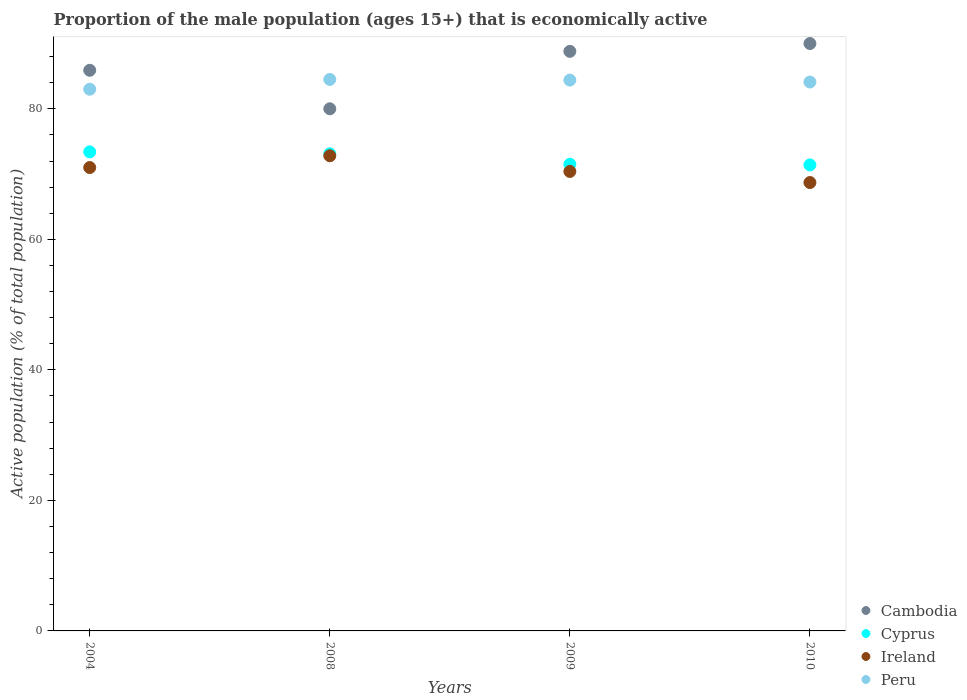What is the proportion of the male population that is economically active in Peru in 2008?
Provide a short and direct response. 84.5. Across all years, what is the maximum proportion of the male population that is economically active in Peru?
Keep it short and to the point. 84.5. What is the total proportion of the male population that is economically active in Ireland in the graph?
Make the answer very short. 282.9. What is the difference between the proportion of the male population that is economically active in Ireland in 2008 and that in 2009?
Offer a very short reply. 2.4. What is the difference between the proportion of the male population that is economically active in Cambodia in 2004 and the proportion of the male population that is economically active in Cyprus in 2010?
Offer a very short reply. 14.5. What is the average proportion of the male population that is economically active in Ireland per year?
Give a very brief answer. 70.73. In the year 2010, what is the difference between the proportion of the male population that is economically active in Peru and proportion of the male population that is economically active in Cambodia?
Provide a succinct answer. -5.9. In how many years, is the proportion of the male population that is economically active in Cyprus greater than 12 %?
Keep it short and to the point. 4. What is the ratio of the proportion of the male population that is economically active in Cyprus in 2008 to that in 2010?
Your answer should be compact. 1.02. What is the difference between the highest and the second highest proportion of the male population that is economically active in Ireland?
Your response must be concise. 1.8. What is the difference between the highest and the lowest proportion of the male population that is economically active in Cyprus?
Provide a succinct answer. 2. Is it the case that in every year, the sum of the proportion of the male population that is economically active in Cyprus and proportion of the male population that is economically active in Peru  is greater than the sum of proportion of the male population that is economically active in Ireland and proportion of the male population that is economically active in Cambodia?
Your answer should be very brief. No. Is it the case that in every year, the sum of the proportion of the male population that is economically active in Cyprus and proportion of the male population that is economically active in Cambodia  is greater than the proportion of the male population that is economically active in Ireland?
Keep it short and to the point. Yes. Does the proportion of the male population that is economically active in Cambodia monotonically increase over the years?
Give a very brief answer. No. Is the proportion of the male population that is economically active in Ireland strictly greater than the proportion of the male population that is economically active in Cyprus over the years?
Provide a short and direct response. No. How many years are there in the graph?
Keep it short and to the point. 4. Are the values on the major ticks of Y-axis written in scientific E-notation?
Offer a terse response. No. Does the graph contain any zero values?
Provide a succinct answer. No. Where does the legend appear in the graph?
Your response must be concise. Bottom right. How are the legend labels stacked?
Give a very brief answer. Vertical. What is the title of the graph?
Keep it short and to the point. Proportion of the male population (ages 15+) that is economically active. What is the label or title of the X-axis?
Your response must be concise. Years. What is the label or title of the Y-axis?
Provide a succinct answer. Active population (% of total population). What is the Active population (% of total population) in Cambodia in 2004?
Provide a short and direct response. 85.9. What is the Active population (% of total population) in Cyprus in 2004?
Give a very brief answer. 73.4. What is the Active population (% of total population) of Ireland in 2004?
Keep it short and to the point. 71. What is the Active population (% of total population) in Peru in 2004?
Make the answer very short. 83. What is the Active population (% of total population) of Cambodia in 2008?
Offer a terse response. 80. What is the Active population (% of total population) of Cyprus in 2008?
Ensure brevity in your answer.  73.1. What is the Active population (% of total population) in Ireland in 2008?
Provide a succinct answer. 72.8. What is the Active population (% of total population) of Peru in 2008?
Your answer should be very brief. 84.5. What is the Active population (% of total population) in Cambodia in 2009?
Ensure brevity in your answer.  88.8. What is the Active population (% of total population) of Cyprus in 2009?
Ensure brevity in your answer.  71.5. What is the Active population (% of total population) in Ireland in 2009?
Give a very brief answer. 70.4. What is the Active population (% of total population) in Peru in 2009?
Keep it short and to the point. 84.4. What is the Active population (% of total population) of Cambodia in 2010?
Your answer should be very brief. 90. What is the Active population (% of total population) in Cyprus in 2010?
Provide a succinct answer. 71.4. What is the Active population (% of total population) in Ireland in 2010?
Keep it short and to the point. 68.7. What is the Active population (% of total population) in Peru in 2010?
Offer a terse response. 84.1. Across all years, what is the maximum Active population (% of total population) in Cambodia?
Ensure brevity in your answer.  90. Across all years, what is the maximum Active population (% of total population) in Cyprus?
Give a very brief answer. 73.4. Across all years, what is the maximum Active population (% of total population) of Ireland?
Provide a succinct answer. 72.8. Across all years, what is the maximum Active population (% of total population) of Peru?
Your answer should be compact. 84.5. Across all years, what is the minimum Active population (% of total population) in Cambodia?
Offer a terse response. 80. Across all years, what is the minimum Active population (% of total population) of Cyprus?
Your response must be concise. 71.4. Across all years, what is the minimum Active population (% of total population) of Ireland?
Your answer should be very brief. 68.7. Across all years, what is the minimum Active population (% of total population) in Peru?
Ensure brevity in your answer.  83. What is the total Active population (% of total population) in Cambodia in the graph?
Offer a terse response. 344.7. What is the total Active population (% of total population) in Cyprus in the graph?
Offer a very short reply. 289.4. What is the total Active population (% of total population) of Ireland in the graph?
Ensure brevity in your answer.  282.9. What is the total Active population (% of total population) of Peru in the graph?
Offer a terse response. 336. What is the difference between the Active population (% of total population) in Peru in 2004 and that in 2008?
Keep it short and to the point. -1.5. What is the difference between the Active population (% of total population) in Peru in 2004 and that in 2009?
Keep it short and to the point. -1.4. What is the difference between the Active population (% of total population) of Cambodia in 2004 and that in 2010?
Give a very brief answer. -4.1. What is the difference between the Active population (% of total population) in Cyprus in 2004 and that in 2010?
Keep it short and to the point. 2. What is the difference between the Active population (% of total population) in Ireland in 2004 and that in 2010?
Your response must be concise. 2.3. What is the difference between the Active population (% of total population) of Cambodia in 2008 and that in 2009?
Keep it short and to the point. -8.8. What is the difference between the Active population (% of total population) in Cyprus in 2008 and that in 2009?
Give a very brief answer. 1.6. What is the difference between the Active population (% of total population) of Ireland in 2008 and that in 2009?
Provide a short and direct response. 2.4. What is the difference between the Active population (% of total population) of Peru in 2008 and that in 2009?
Your response must be concise. 0.1. What is the difference between the Active population (% of total population) in Cambodia in 2008 and that in 2010?
Keep it short and to the point. -10. What is the difference between the Active population (% of total population) of Cyprus in 2008 and that in 2010?
Ensure brevity in your answer.  1.7. What is the difference between the Active population (% of total population) in Peru in 2008 and that in 2010?
Offer a very short reply. 0.4. What is the difference between the Active population (% of total population) in Cambodia in 2009 and that in 2010?
Your response must be concise. -1.2. What is the difference between the Active population (% of total population) in Cyprus in 2009 and that in 2010?
Provide a short and direct response. 0.1. What is the difference between the Active population (% of total population) in Ireland in 2009 and that in 2010?
Make the answer very short. 1.7. What is the difference between the Active population (% of total population) of Peru in 2009 and that in 2010?
Provide a short and direct response. 0.3. What is the difference between the Active population (% of total population) of Cambodia in 2004 and the Active population (% of total population) of Ireland in 2008?
Make the answer very short. 13.1. What is the difference between the Active population (% of total population) of Cyprus in 2004 and the Active population (% of total population) of Ireland in 2008?
Offer a very short reply. 0.6. What is the difference between the Active population (% of total population) of Cambodia in 2004 and the Active population (% of total population) of Peru in 2009?
Your answer should be very brief. 1.5. What is the difference between the Active population (% of total population) of Cyprus in 2004 and the Active population (% of total population) of Ireland in 2009?
Provide a short and direct response. 3. What is the difference between the Active population (% of total population) of Ireland in 2004 and the Active population (% of total population) of Peru in 2009?
Your answer should be very brief. -13.4. What is the difference between the Active population (% of total population) in Cambodia in 2004 and the Active population (% of total population) in Cyprus in 2010?
Offer a very short reply. 14.5. What is the difference between the Active population (% of total population) of Ireland in 2004 and the Active population (% of total population) of Peru in 2010?
Keep it short and to the point. -13.1. What is the difference between the Active population (% of total population) of Cambodia in 2008 and the Active population (% of total population) of Cyprus in 2009?
Make the answer very short. 8.5. What is the difference between the Active population (% of total population) of Cambodia in 2008 and the Active population (% of total population) of Ireland in 2009?
Keep it short and to the point. 9.6. What is the difference between the Active population (% of total population) of Cambodia in 2008 and the Active population (% of total population) of Peru in 2009?
Your response must be concise. -4.4. What is the difference between the Active population (% of total population) of Cyprus in 2008 and the Active population (% of total population) of Ireland in 2010?
Provide a short and direct response. 4.4. What is the difference between the Active population (% of total population) in Cyprus in 2008 and the Active population (% of total population) in Peru in 2010?
Provide a succinct answer. -11. What is the difference between the Active population (% of total population) in Ireland in 2008 and the Active population (% of total population) in Peru in 2010?
Your response must be concise. -11.3. What is the difference between the Active population (% of total population) of Cambodia in 2009 and the Active population (% of total population) of Cyprus in 2010?
Offer a terse response. 17.4. What is the difference between the Active population (% of total population) of Cambodia in 2009 and the Active population (% of total population) of Ireland in 2010?
Provide a succinct answer. 20.1. What is the difference between the Active population (% of total population) in Cambodia in 2009 and the Active population (% of total population) in Peru in 2010?
Your answer should be compact. 4.7. What is the difference between the Active population (% of total population) of Cyprus in 2009 and the Active population (% of total population) of Ireland in 2010?
Ensure brevity in your answer.  2.8. What is the difference between the Active population (% of total population) in Ireland in 2009 and the Active population (% of total population) in Peru in 2010?
Provide a succinct answer. -13.7. What is the average Active population (% of total population) of Cambodia per year?
Your answer should be compact. 86.17. What is the average Active population (% of total population) in Cyprus per year?
Keep it short and to the point. 72.35. What is the average Active population (% of total population) of Ireland per year?
Offer a very short reply. 70.72. What is the average Active population (% of total population) of Peru per year?
Make the answer very short. 84. In the year 2004, what is the difference between the Active population (% of total population) in Cambodia and Active population (% of total population) in Cyprus?
Offer a very short reply. 12.5. In the year 2008, what is the difference between the Active population (% of total population) of Cambodia and Active population (% of total population) of Peru?
Ensure brevity in your answer.  -4.5. In the year 2008, what is the difference between the Active population (% of total population) in Cyprus and Active population (% of total population) in Ireland?
Offer a very short reply. 0.3. In the year 2008, what is the difference between the Active population (% of total population) of Cyprus and Active population (% of total population) of Peru?
Make the answer very short. -11.4. In the year 2009, what is the difference between the Active population (% of total population) of Cambodia and Active population (% of total population) of Cyprus?
Ensure brevity in your answer.  17.3. In the year 2009, what is the difference between the Active population (% of total population) of Cambodia and Active population (% of total population) of Ireland?
Your response must be concise. 18.4. In the year 2009, what is the difference between the Active population (% of total population) in Cambodia and Active population (% of total population) in Peru?
Offer a terse response. 4.4. In the year 2010, what is the difference between the Active population (% of total population) in Cambodia and Active population (% of total population) in Cyprus?
Offer a very short reply. 18.6. In the year 2010, what is the difference between the Active population (% of total population) in Cambodia and Active population (% of total population) in Ireland?
Offer a very short reply. 21.3. In the year 2010, what is the difference between the Active population (% of total population) of Cambodia and Active population (% of total population) of Peru?
Offer a very short reply. 5.9. In the year 2010, what is the difference between the Active population (% of total population) in Cyprus and Active population (% of total population) in Ireland?
Make the answer very short. 2.7. In the year 2010, what is the difference between the Active population (% of total population) of Cyprus and Active population (% of total population) of Peru?
Keep it short and to the point. -12.7. In the year 2010, what is the difference between the Active population (% of total population) in Ireland and Active population (% of total population) in Peru?
Offer a very short reply. -15.4. What is the ratio of the Active population (% of total population) of Cambodia in 2004 to that in 2008?
Your answer should be very brief. 1.07. What is the ratio of the Active population (% of total population) in Cyprus in 2004 to that in 2008?
Provide a short and direct response. 1. What is the ratio of the Active population (% of total population) in Ireland in 2004 to that in 2008?
Provide a short and direct response. 0.98. What is the ratio of the Active population (% of total population) of Peru in 2004 to that in 2008?
Provide a succinct answer. 0.98. What is the ratio of the Active population (% of total population) in Cambodia in 2004 to that in 2009?
Your response must be concise. 0.97. What is the ratio of the Active population (% of total population) of Cyprus in 2004 to that in 2009?
Your answer should be very brief. 1.03. What is the ratio of the Active population (% of total population) of Ireland in 2004 to that in 2009?
Give a very brief answer. 1.01. What is the ratio of the Active population (% of total population) of Peru in 2004 to that in 2009?
Offer a very short reply. 0.98. What is the ratio of the Active population (% of total population) of Cambodia in 2004 to that in 2010?
Provide a succinct answer. 0.95. What is the ratio of the Active population (% of total population) in Cyprus in 2004 to that in 2010?
Your response must be concise. 1.03. What is the ratio of the Active population (% of total population) in Ireland in 2004 to that in 2010?
Your answer should be very brief. 1.03. What is the ratio of the Active population (% of total population) of Peru in 2004 to that in 2010?
Provide a succinct answer. 0.99. What is the ratio of the Active population (% of total population) of Cambodia in 2008 to that in 2009?
Provide a short and direct response. 0.9. What is the ratio of the Active population (% of total population) of Cyprus in 2008 to that in 2009?
Ensure brevity in your answer.  1.02. What is the ratio of the Active population (% of total population) of Ireland in 2008 to that in 2009?
Offer a terse response. 1.03. What is the ratio of the Active population (% of total population) of Cyprus in 2008 to that in 2010?
Your response must be concise. 1.02. What is the ratio of the Active population (% of total population) of Ireland in 2008 to that in 2010?
Your answer should be very brief. 1.06. What is the ratio of the Active population (% of total population) in Cambodia in 2009 to that in 2010?
Offer a very short reply. 0.99. What is the ratio of the Active population (% of total population) of Cyprus in 2009 to that in 2010?
Keep it short and to the point. 1. What is the ratio of the Active population (% of total population) of Ireland in 2009 to that in 2010?
Your response must be concise. 1.02. What is the difference between the highest and the second highest Active population (% of total population) of Cambodia?
Keep it short and to the point. 1.2. What is the difference between the highest and the second highest Active population (% of total population) in Cyprus?
Make the answer very short. 0.3. What is the difference between the highest and the second highest Active population (% of total population) in Ireland?
Give a very brief answer. 1.8. What is the difference between the highest and the second highest Active population (% of total population) of Peru?
Give a very brief answer. 0.1. What is the difference between the highest and the lowest Active population (% of total population) of Cambodia?
Make the answer very short. 10. 